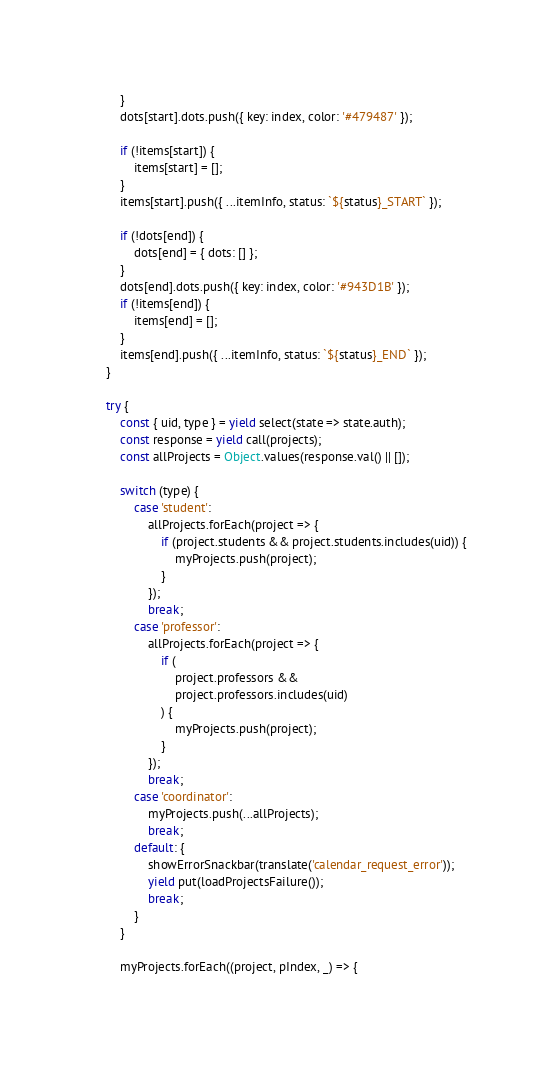<code> <loc_0><loc_0><loc_500><loc_500><_JavaScript_>        }
        dots[start].dots.push({ key: index, color: '#479487' });

        if (!items[start]) {
            items[start] = [];
        }
        items[start].push({ ...itemInfo, status: `${status}_START` });

        if (!dots[end]) {
            dots[end] = { dots: [] };
        }
        dots[end].dots.push({ key: index, color: '#943D1B' });
        if (!items[end]) {
            items[end] = [];
        }
        items[end].push({ ...itemInfo, status: `${status}_END` });
    }

    try {
        const { uid, type } = yield select(state => state.auth);
        const response = yield call(projects);
        const allProjects = Object.values(response.val() || []);

        switch (type) {
            case 'student':
                allProjects.forEach(project => {
                    if (project.students && project.students.includes(uid)) {
                        myProjects.push(project);
                    }
                });
                break;
            case 'professor':
                allProjects.forEach(project => {
                    if (
                        project.professors &&
                        project.professors.includes(uid)
                    ) {
                        myProjects.push(project);
                    }
                });
                break;
            case 'coordinator':
                myProjects.push(...allProjects);
                break;
            default: {
                showErrorSnackbar(translate('calendar_request_error'));
                yield put(loadProjectsFailure());
                break;
            }
        }

        myProjects.forEach((project, pIndex, _) => {</code> 